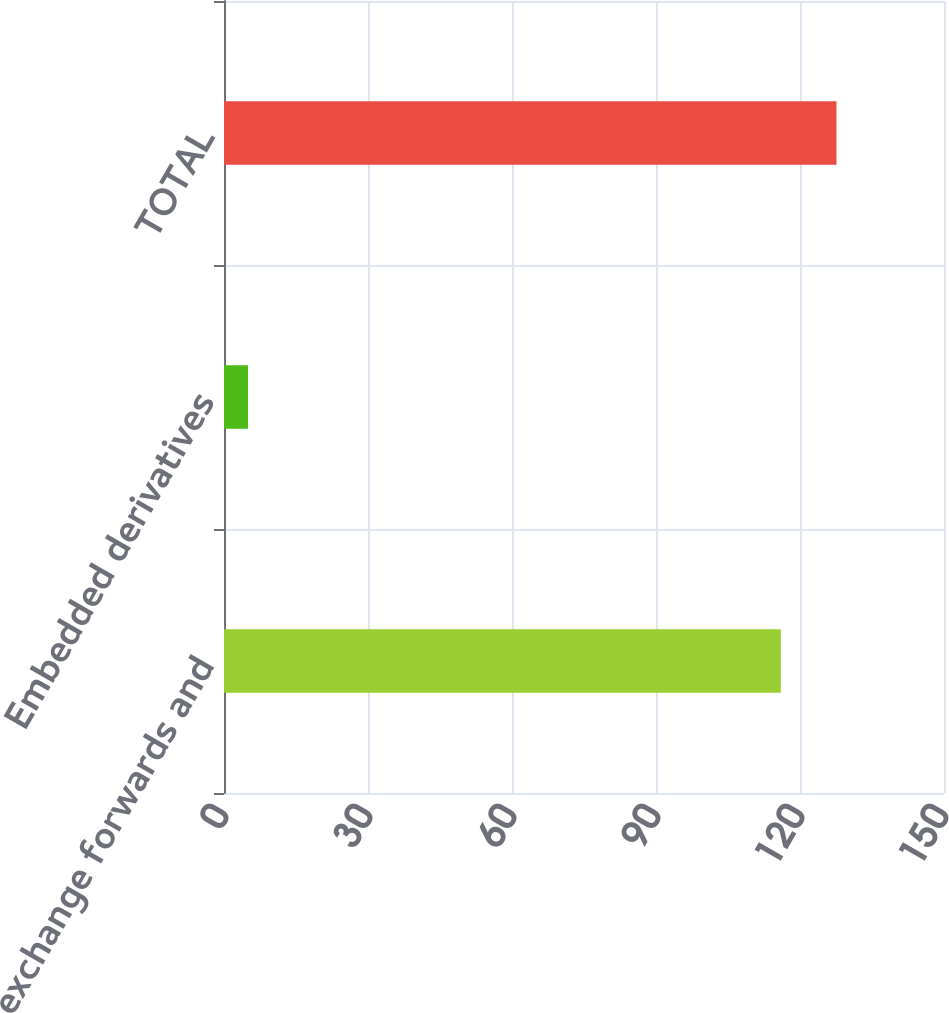Convert chart. <chart><loc_0><loc_0><loc_500><loc_500><bar_chart><fcel>Foreign exchange forwards and<fcel>Embedded derivatives<fcel>TOTAL<nl><fcel>116<fcel>5<fcel>127.6<nl></chart> 